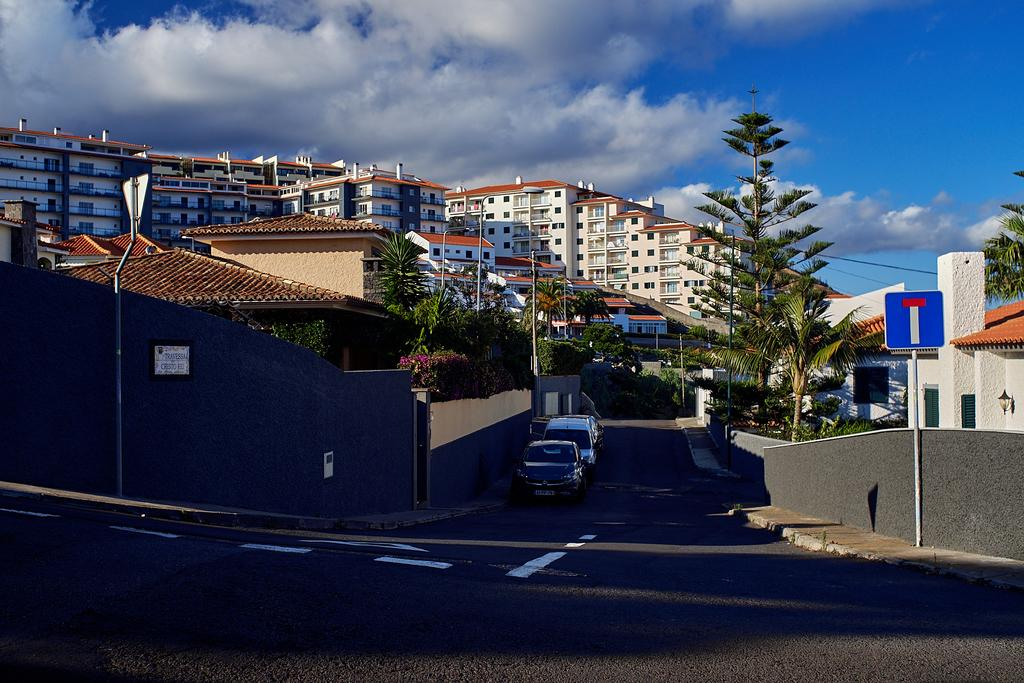What type of structures can be seen in the image? There are buildings in the image. What other natural elements are present in the image? There are trees in the image. What man-made objects can be seen in the image? There are poles and vehicles in the image. What is the main feature of the image that connects the buildings and vehicles? There is a road in the image that connects the buildings and vehicles. What else can be seen in the image besides the buildings, trees, poles, vehicles, and road? There are other objects in the image. What part of the natural environment is visible in the image? The sky is visible at the top of the image. How many girls are playing in the year depicted in the image? There are no girls present in the image, and no specific year is mentioned. 